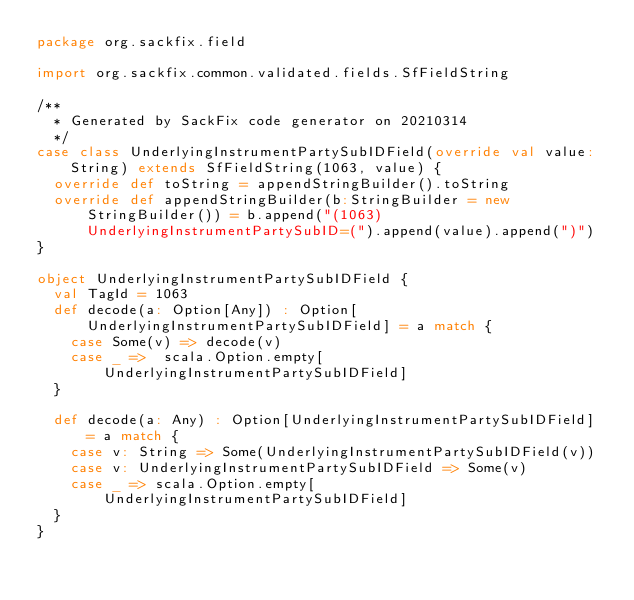Convert code to text. <code><loc_0><loc_0><loc_500><loc_500><_Scala_>package org.sackfix.field

import org.sackfix.common.validated.fields.SfFieldString

/**
  * Generated by SackFix code generator on 20210314
  */
case class UnderlyingInstrumentPartySubIDField(override val value: String) extends SfFieldString(1063, value) {
  override def toString = appendStringBuilder().toString
  override def appendStringBuilder(b:StringBuilder = new StringBuilder()) = b.append("(1063)UnderlyingInstrumentPartySubID=(").append(value).append(")")
}

object UnderlyingInstrumentPartySubIDField {
  val TagId = 1063  
  def decode(a: Option[Any]) : Option[UnderlyingInstrumentPartySubIDField] = a match {
    case Some(v) => decode(v)
    case _ =>  scala.Option.empty[UnderlyingInstrumentPartySubIDField]
  }

  def decode(a: Any) : Option[UnderlyingInstrumentPartySubIDField] = a match {
    case v: String => Some(UnderlyingInstrumentPartySubIDField(v))
    case v: UnderlyingInstrumentPartySubIDField => Some(v)
    case _ => scala.Option.empty[UnderlyingInstrumentPartySubIDField]
  } 
}
</code> 